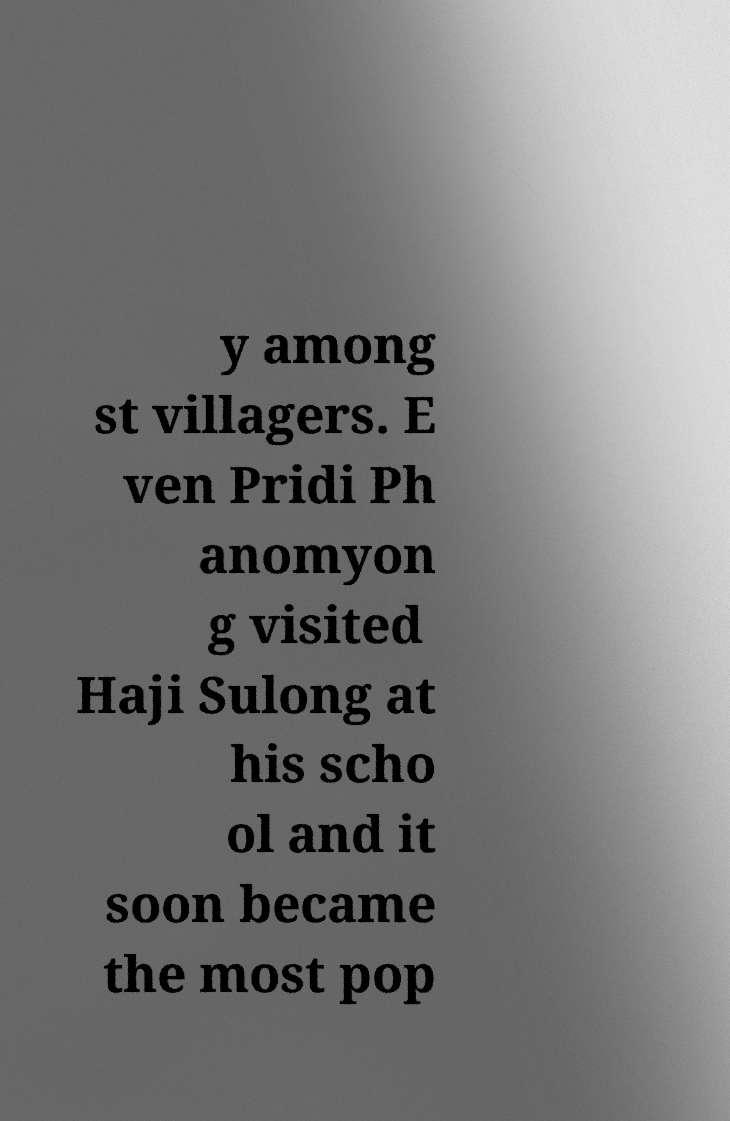For documentation purposes, I need the text within this image transcribed. Could you provide that? y among st villagers. E ven Pridi Ph anomyon g visited Haji Sulong at his scho ol and it soon became the most pop 